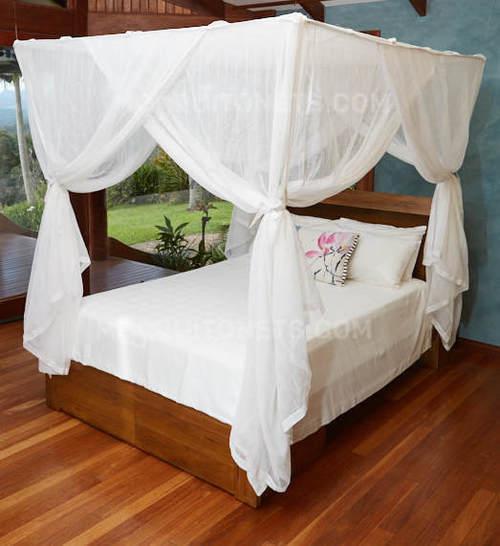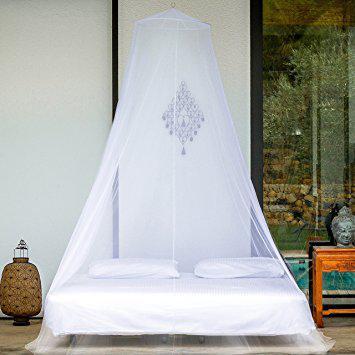The first image is the image on the left, the second image is the image on the right. Assess this claim about the two images: "One bed has a rectangular canopy that ties at each corner, like a drape.". Correct or not? Answer yes or no. Yes. 